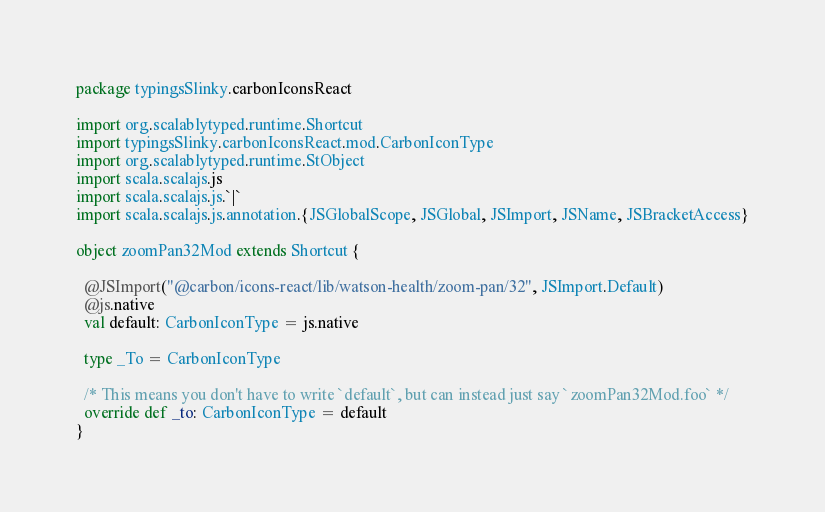Convert code to text. <code><loc_0><loc_0><loc_500><loc_500><_Scala_>package typingsSlinky.carbonIconsReact

import org.scalablytyped.runtime.Shortcut
import typingsSlinky.carbonIconsReact.mod.CarbonIconType
import org.scalablytyped.runtime.StObject
import scala.scalajs.js
import scala.scalajs.js.`|`
import scala.scalajs.js.annotation.{JSGlobalScope, JSGlobal, JSImport, JSName, JSBracketAccess}

object zoomPan32Mod extends Shortcut {
  
  @JSImport("@carbon/icons-react/lib/watson-health/zoom-pan/32", JSImport.Default)
  @js.native
  val default: CarbonIconType = js.native
  
  type _To = CarbonIconType
  
  /* This means you don't have to write `default`, but can instead just say `zoomPan32Mod.foo` */
  override def _to: CarbonIconType = default
}
</code> 